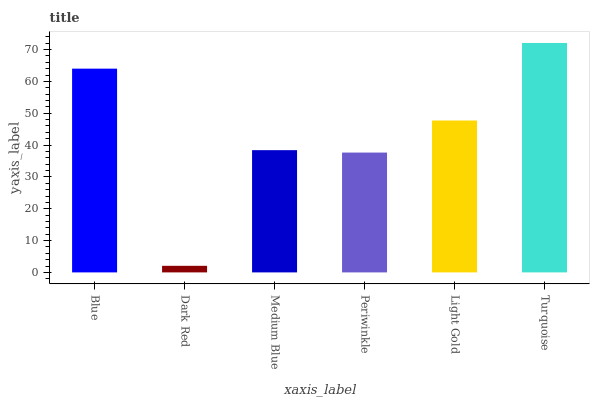Is Dark Red the minimum?
Answer yes or no. Yes. Is Turquoise the maximum?
Answer yes or no. Yes. Is Medium Blue the minimum?
Answer yes or no. No. Is Medium Blue the maximum?
Answer yes or no. No. Is Medium Blue greater than Dark Red?
Answer yes or no. Yes. Is Dark Red less than Medium Blue?
Answer yes or no. Yes. Is Dark Red greater than Medium Blue?
Answer yes or no. No. Is Medium Blue less than Dark Red?
Answer yes or no. No. Is Light Gold the high median?
Answer yes or no. Yes. Is Medium Blue the low median?
Answer yes or no. Yes. Is Dark Red the high median?
Answer yes or no. No. Is Periwinkle the low median?
Answer yes or no. No. 